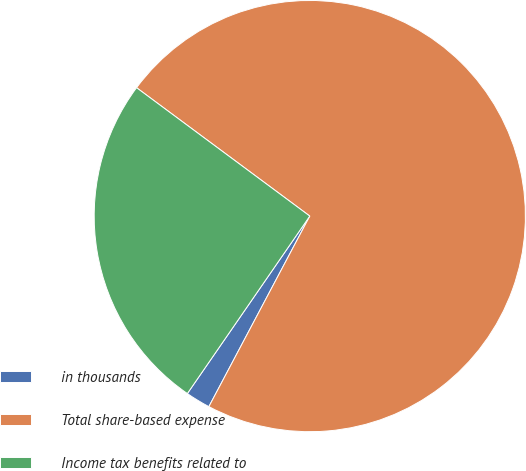Convert chart. <chart><loc_0><loc_0><loc_500><loc_500><pie_chart><fcel>in thousands<fcel>Total share-based expense<fcel>Income tax benefits related to<nl><fcel>1.86%<fcel>72.6%<fcel>25.54%<nl></chart> 